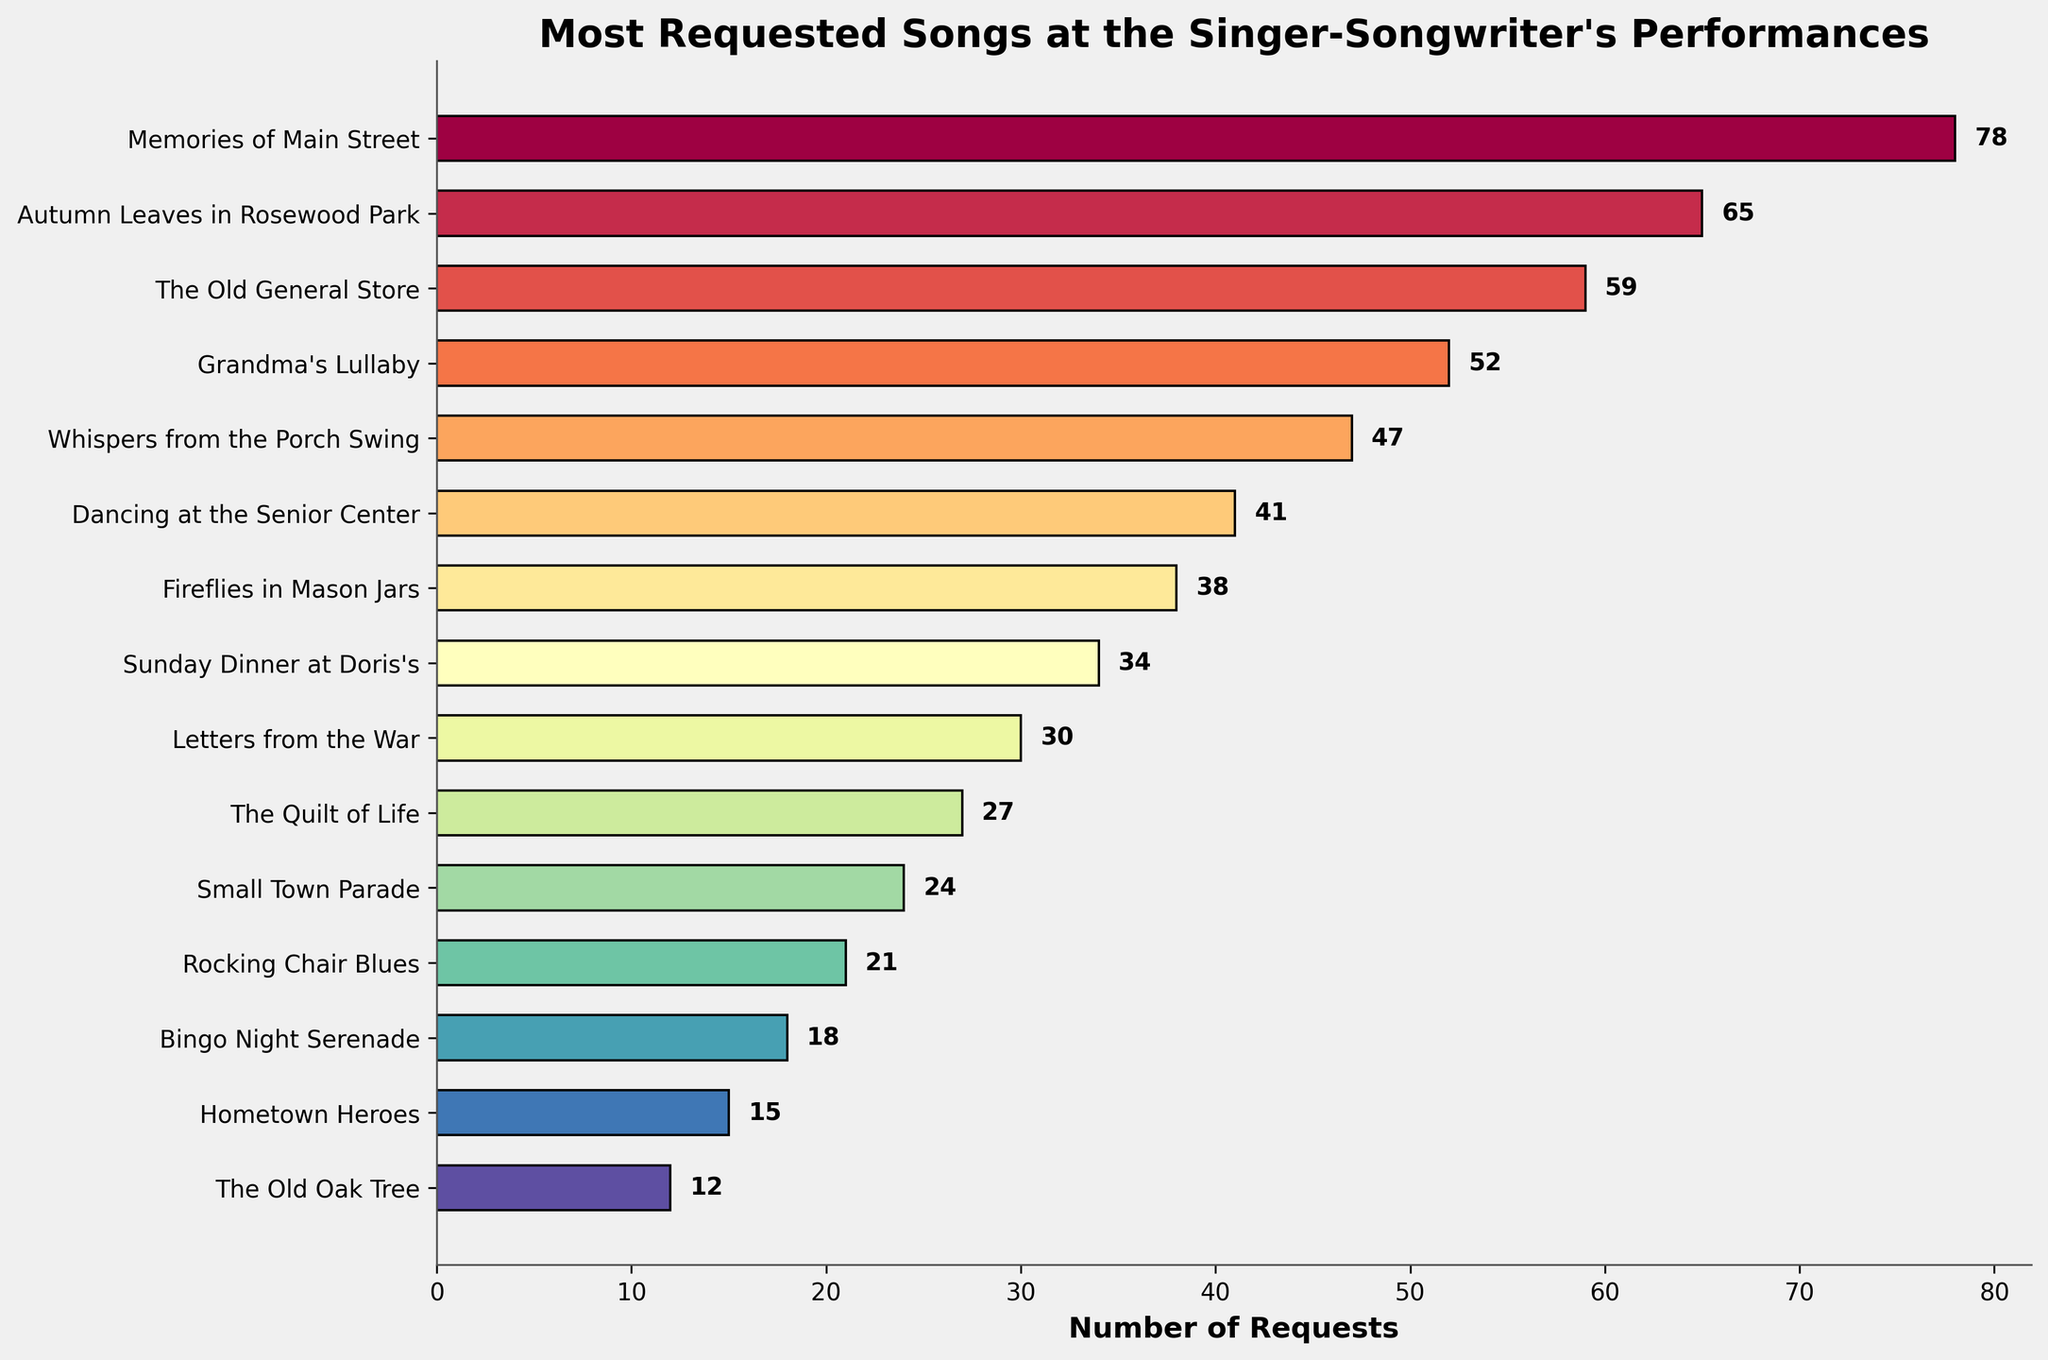Which song has the most requests? The song with the greatest number of requests will have the longest bar in the chart. From the figure, "Memories of Main Street" has the longest bar with 78 requests.
Answer: "Memories of Main Street" How many more requests does "Memories of Main Street" have than "The Old General Store"? "Memories of Main Street" has 78 requests and "The Old General Store" has 59 requests. The difference is 78 - 59.
Answer: 19 Which two songs combined have the fewest requests? Identify the two shortest bars on the chart. "The Old Oak Tree" and "Hometown Heroes" have the fewest requests with 12 and 15 requests respectively. Their total is 12 + 15.
Answer: "The Old Oak Tree" and "Hometown Heroes" What is the total number of requests for "Sunday Dinner at Doris's" and "Fireflies in Mason Jars"? Find the number of requests for both songs and add them. "Sunday Dinner at Doris's" has 34 requests and "Fireflies in Mason Jars" has 38 requests. Their total is 34 + 38.
Answer: 72 How many songs received more than 50 requests? Count the number of bars longer than the 50 mark. Three songs—"Memories of Main Street", "Autumn Leaves in Rosewood Park", and "The Old General Store"—have more than 50 requests.
Answer: 3 Which song has the third highest number of requests? Order the songs by the length of their bars. The third longest bar belongs to "The Old General Store" with 59 requests.
Answer: "The Old General Store" What is the average number of requests for the top 5 most requested songs? First, sum the number of requests for the top 5 songs: 78 + 65 + 59 + 52 + 47. Then divide by 5. The sum is 301 and the average is 301 / 5.
Answer: 60.2 Compare the number of requests for "Whispers from the Porch Swing" and "Dancing at the Senior Center". Which song has more requests? Look at the bars associated with these songs. "Whispers from the Porch Swing" has 47 requests and "Dancing at the Senior Center" has 41 requests. Therefore, "Whispers from the Porch Swing" has more requests.
Answer: "Whispers from the Porch Swing" How many requests are there in total for all songs less requested than "Grandma's Lullaby"? Add the requests for all the songs below "Grandma's Lullaby" (52 requests). These are: 47 + 41 + 38 + 34 + 30 + 27 + 24 + 21 + 18 + 15 + 12. The total sum is 307.
Answer: 307 